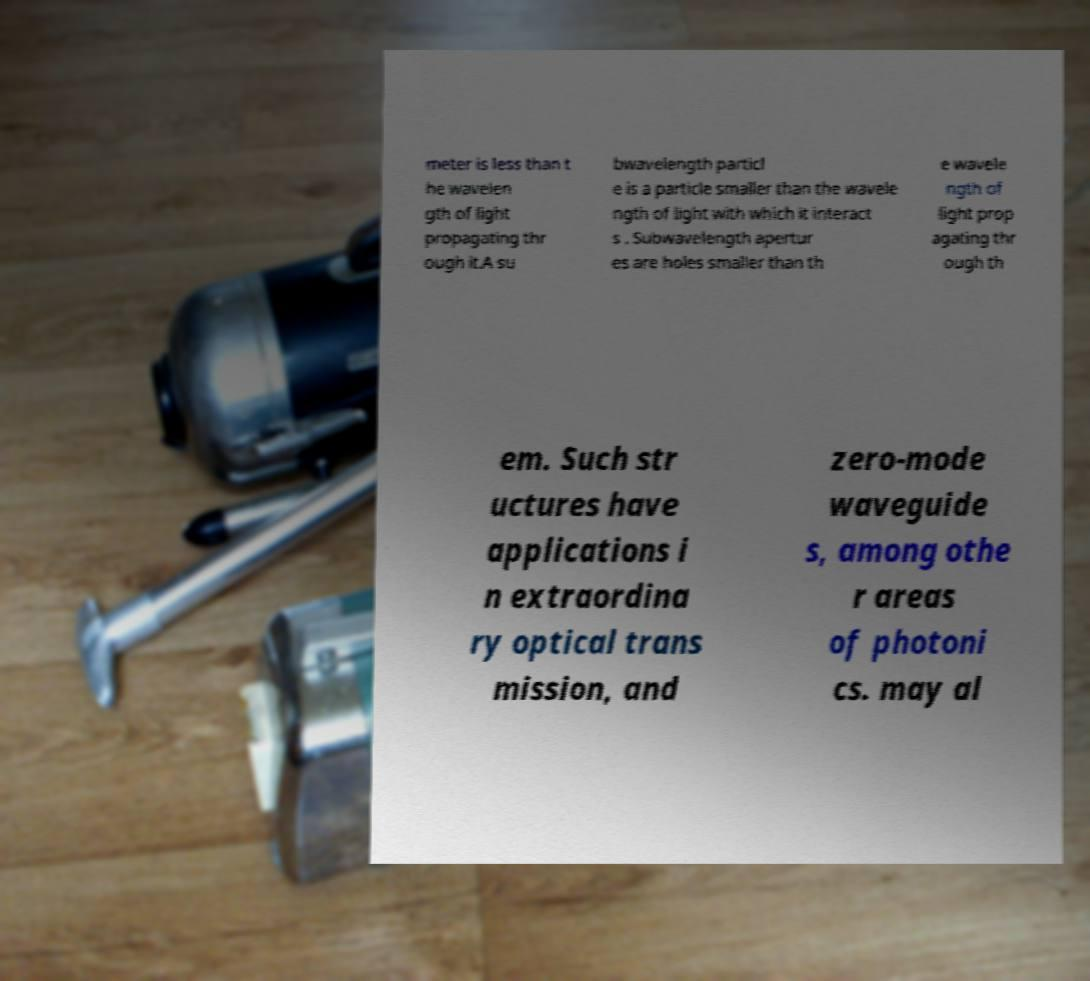There's text embedded in this image that I need extracted. Can you transcribe it verbatim? meter is less than t he wavelen gth of light propagating thr ough it.A su bwavelength particl e is a particle smaller than the wavele ngth of light with which it interact s . Subwavelength apertur es are holes smaller than th e wavele ngth of light prop agating thr ough th em. Such str uctures have applications i n extraordina ry optical trans mission, and zero-mode waveguide s, among othe r areas of photoni cs. may al 